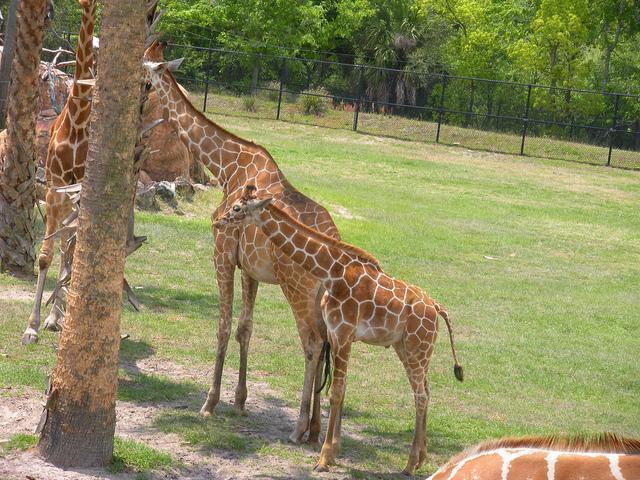Why are the animals enclosed in one area?
Select the correct answer and articulate reasoning with the following format: 'Answer: answer
Rationale: rationale.'
Options: To protect, to hunt, to capture, to heal. Answer: to protect.
Rationale: The animals are in the area protected by a fence. 